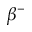<formula> <loc_0><loc_0><loc_500><loc_500>\beta ^ { - }</formula> 